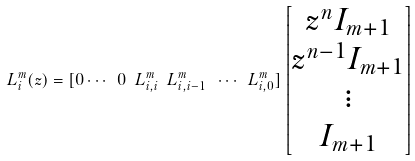Convert formula to latex. <formula><loc_0><loc_0><loc_500><loc_500>L ^ { m } _ { i } ( z ) = [ 0 \cdots \ 0 \ L ^ { m } _ { i , i } \ L ^ { m } _ { i , i - 1 } \ \cdots \ L ^ { m } _ { i , 0 } ] \left [ \begin{matrix} z ^ { n } I _ { m + 1 } \\ z ^ { n - 1 } I _ { m + 1 } \\ \vdots \\ I _ { m + 1 } \end{matrix} \right ]</formula> 